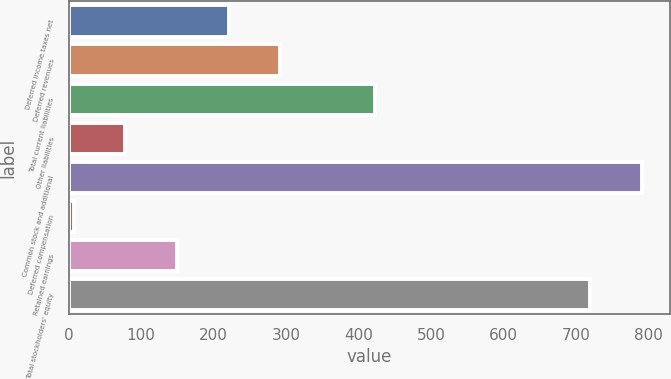Convert chart. <chart><loc_0><loc_0><loc_500><loc_500><bar_chart><fcel>Deferred income taxes net<fcel>Deferred revenues<fcel>Total current liabilities<fcel>Other liabilities<fcel>Common stock and additional<fcel>Deferred compensation<fcel>Retained earnings<fcel>Total stockholders' equity<nl><fcel>220.55<fcel>291.8<fcel>422.2<fcel>78.05<fcel>790.45<fcel>6.8<fcel>149.3<fcel>719.2<nl></chart> 